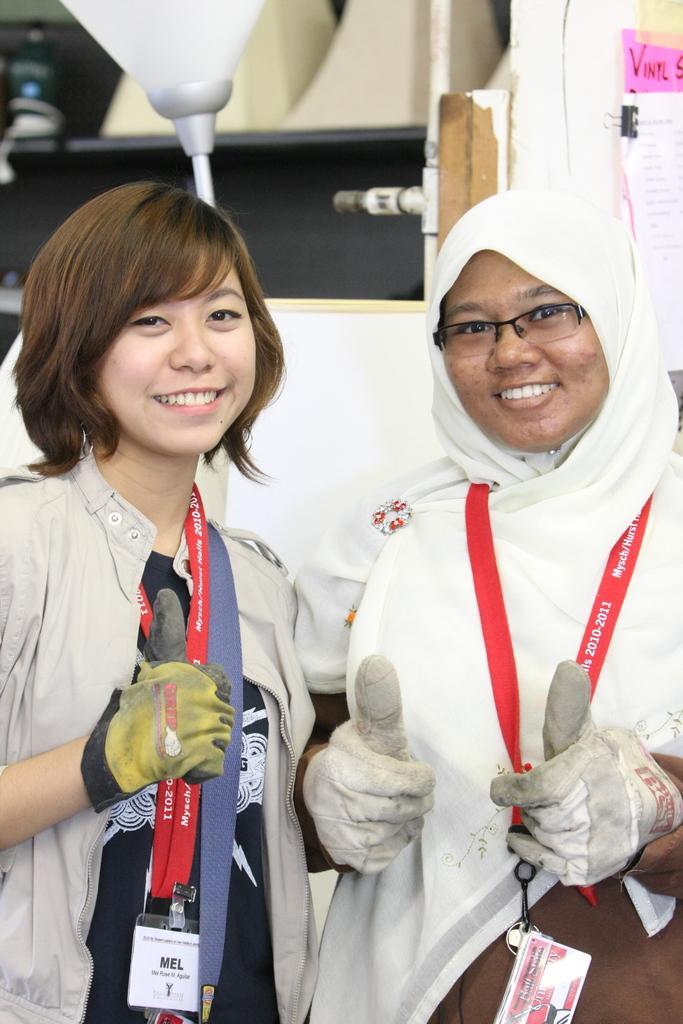Can you describe this image briefly? In this image there are two women standing. They are smiling. They are wearing identity cards and gloves. Behind them there is a wall. In the top right there is a binder clip to the papers. There is text on the papers. 